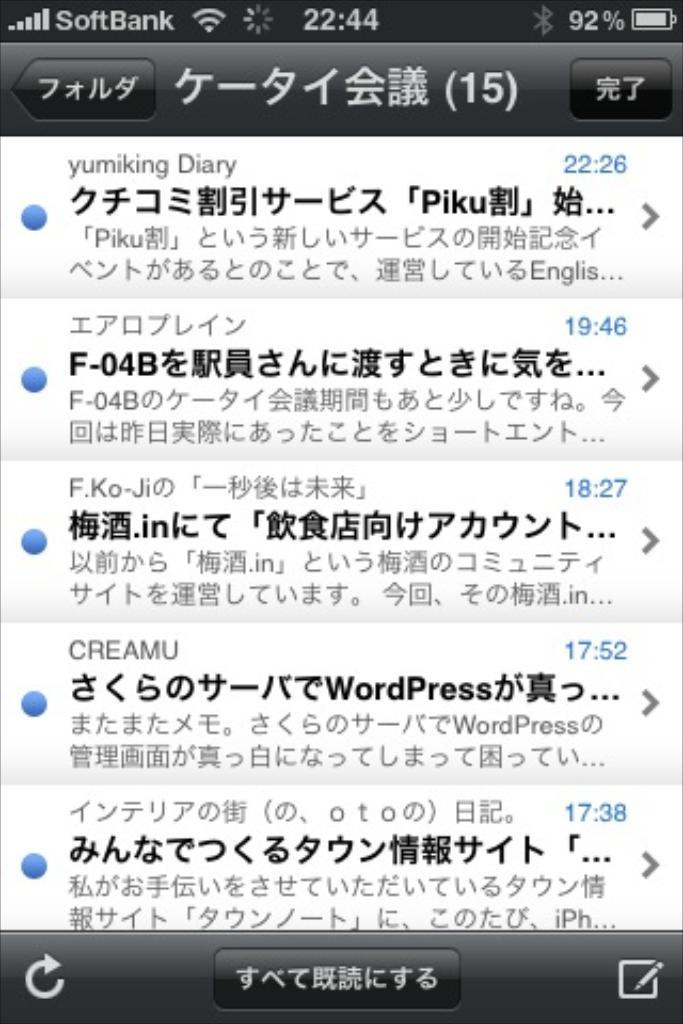What percentage battery life is left on the phone?
Provide a short and direct response. 92. What time is it on the phone?
Your answer should be compact. 22:44. 